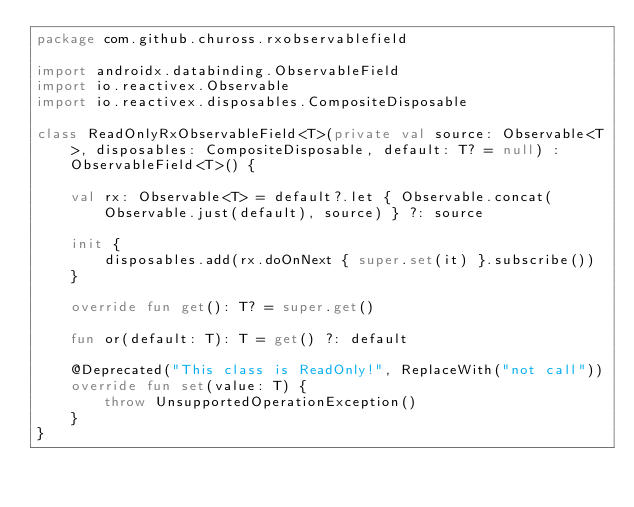Convert code to text. <code><loc_0><loc_0><loc_500><loc_500><_Kotlin_>package com.github.chuross.rxobservablefield

import androidx.databinding.ObservableField
import io.reactivex.Observable
import io.reactivex.disposables.CompositeDisposable

class ReadOnlyRxObservableField<T>(private val source: Observable<T>, disposables: CompositeDisposable, default: T? = null) : ObservableField<T>() {

    val rx: Observable<T> = default?.let { Observable.concat(Observable.just(default), source) } ?: source

    init {
        disposables.add(rx.doOnNext { super.set(it) }.subscribe())
    }

    override fun get(): T? = super.get()

    fun or(default: T): T = get() ?: default

    @Deprecated("This class is ReadOnly!", ReplaceWith("not call"))
    override fun set(value: T) {
        throw UnsupportedOperationException()
    }
}
</code> 